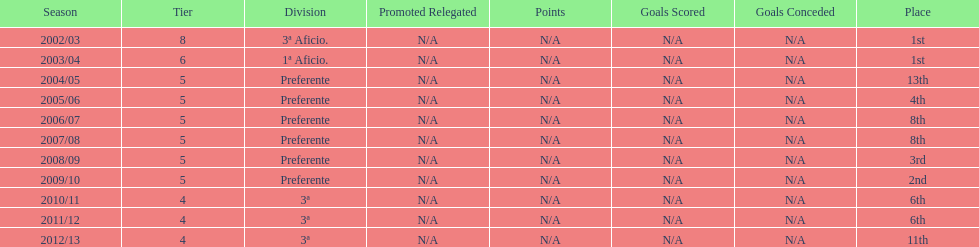How long has internacional de madrid cf been playing in the 3ª division? 3. 